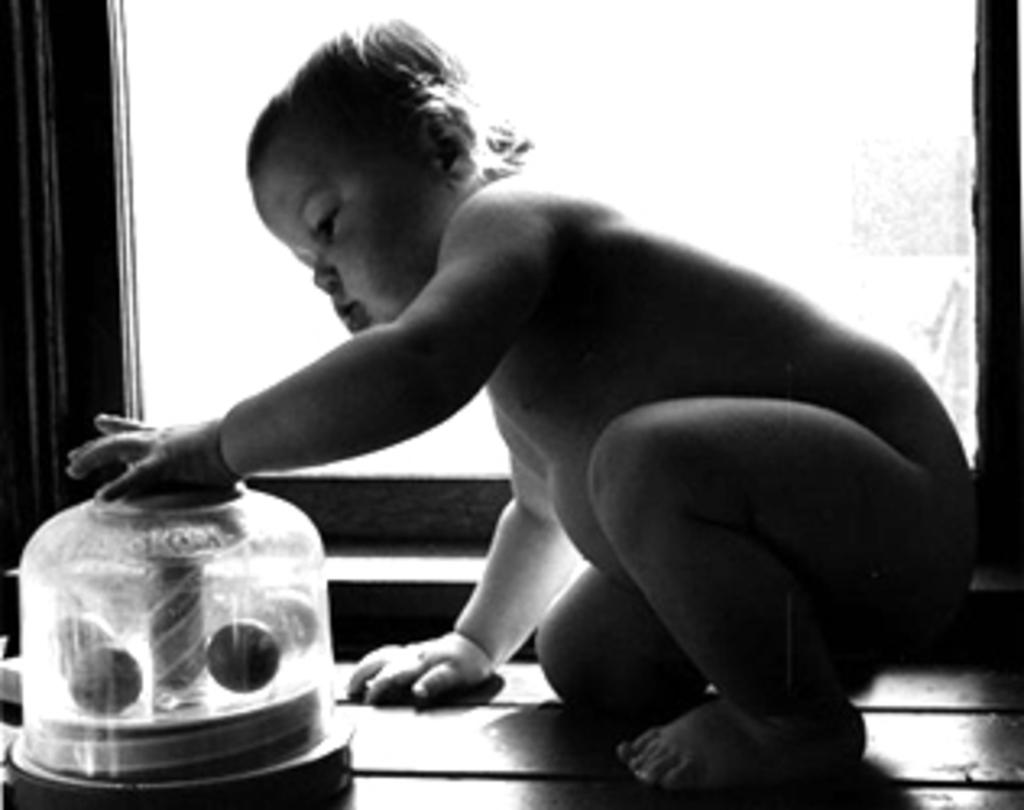What is the main subject of the image? The main subject of the image is a child. Can you describe any objects in the image? There is an object truncated towards the bottom of the image, and a window truncated in the background. What is the child comparing in the image? There is no indication in the image that the child is comparing anything. How many cats can be seen in the image? There are no cats present in the image. 